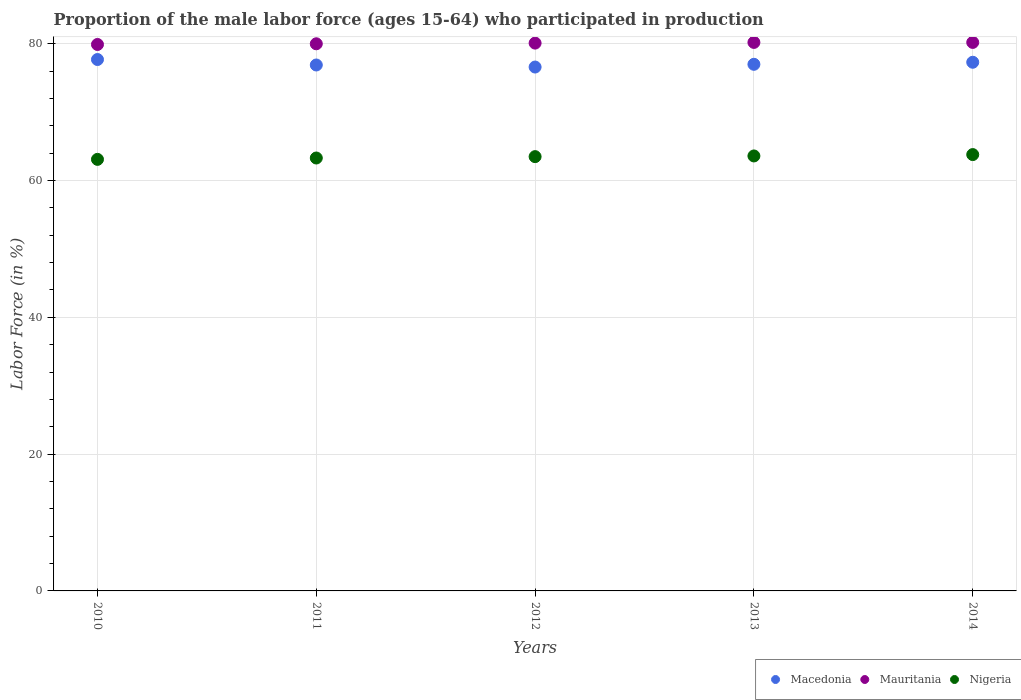What is the proportion of the male labor force who participated in production in Macedonia in 2012?
Offer a very short reply. 76.6. Across all years, what is the maximum proportion of the male labor force who participated in production in Mauritania?
Provide a short and direct response. 80.2. Across all years, what is the minimum proportion of the male labor force who participated in production in Macedonia?
Offer a very short reply. 76.6. What is the total proportion of the male labor force who participated in production in Macedonia in the graph?
Offer a terse response. 385.5. What is the difference between the proportion of the male labor force who participated in production in Macedonia in 2013 and that in 2014?
Offer a terse response. -0.3. What is the difference between the proportion of the male labor force who participated in production in Mauritania in 2012 and the proportion of the male labor force who participated in production in Macedonia in 2010?
Provide a succinct answer. 2.4. What is the average proportion of the male labor force who participated in production in Macedonia per year?
Ensure brevity in your answer.  77.1. In the year 2010, what is the difference between the proportion of the male labor force who participated in production in Nigeria and proportion of the male labor force who participated in production in Mauritania?
Your answer should be very brief. -16.8. In how many years, is the proportion of the male labor force who participated in production in Macedonia greater than 64 %?
Ensure brevity in your answer.  5. What is the ratio of the proportion of the male labor force who participated in production in Mauritania in 2011 to that in 2012?
Make the answer very short. 1. What is the difference between the highest and the second highest proportion of the male labor force who participated in production in Macedonia?
Make the answer very short. 0.4. What is the difference between the highest and the lowest proportion of the male labor force who participated in production in Mauritania?
Ensure brevity in your answer.  0.3. In how many years, is the proportion of the male labor force who participated in production in Mauritania greater than the average proportion of the male labor force who participated in production in Mauritania taken over all years?
Make the answer very short. 3. Does the proportion of the male labor force who participated in production in Macedonia monotonically increase over the years?
Provide a short and direct response. No. Is the proportion of the male labor force who participated in production in Mauritania strictly greater than the proportion of the male labor force who participated in production in Nigeria over the years?
Your answer should be very brief. Yes. Is the proportion of the male labor force who participated in production in Macedonia strictly less than the proportion of the male labor force who participated in production in Mauritania over the years?
Your answer should be compact. Yes. How many years are there in the graph?
Your response must be concise. 5. Does the graph contain any zero values?
Your answer should be compact. No. Does the graph contain grids?
Your answer should be compact. Yes. What is the title of the graph?
Your response must be concise. Proportion of the male labor force (ages 15-64) who participated in production. Does "Latin America(developing only)" appear as one of the legend labels in the graph?
Make the answer very short. No. What is the label or title of the X-axis?
Ensure brevity in your answer.  Years. What is the label or title of the Y-axis?
Your response must be concise. Labor Force (in %). What is the Labor Force (in %) in Macedonia in 2010?
Keep it short and to the point. 77.7. What is the Labor Force (in %) of Mauritania in 2010?
Your answer should be compact. 79.9. What is the Labor Force (in %) of Nigeria in 2010?
Provide a succinct answer. 63.1. What is the Labor Force (in %) of Macedonia in 2011?
Ensure brevity in your answer.  76.9. What is the Labor Force (in %) of Nigeria in 2011?
Keep it short and to the point. 63.3. What is the Labor Force (in %) of Macedonia in 2012?
Ensure brevity in your answer.  76.6. What is the Labor Force (in %) of Mauritania in 2012?
Ensure brevity in your answer.  80.1. What is the Labor Force (in %) of Nigeria in 2012?
Offer a very short reply. 63.5. What is the Labor Force (in %) of Macedonia in 2013?
Ensure brevity in your answer.  77. What is the Labor Force (in %) of Mauritania in 2013?
Your answer should be very brief. 80.2. What is the Labor Force (in %) of Nigeria in 2013?
Provide a succinct answer. 63.6. What is the Labor Force (in %) in Macedonia in 2014?
Provide a short and direct response. 77.3. What is the Labor Force (in %) in Mauritania in 2014?
Your answer should be compact. 80.2. What is the Labor Force (in %) of Nigeria in 2014?
Give a very brief answer. 63.8. Across all years, what is the maximum Labor Force (in %) in Macedonia?
Ensure brevity in your answer.  77.7. Across all years, what is the maximum Labor Force (in %) in Mauritania?
Offer a very short reply. 80.2. Across all years, what is the maximum Labor Force (in %) of Nigeria?
Keep it short and to the point. 63.8. Across all years, what is the minimum Labor Force (in %) of Macedonia?
Ensure brevity in your answer.  76.6. Across all years, what is the minimum Labor Force (in %) of Mauritania?
Keep it short and to the point. 79.9. Across all years, what is the minimum Labor Force (in %) in Nigeria?
Offer a terse response. 63.1. What is the total Labor Force (in %) of Macedonia in the graph?
Your answer should be very brief. 385.5. What is the total Labor Force (in %) of Mauritania in the graph?
Offer a terse response. 400.4. What is the total Labor Force (in %) in Nigeria in the graph?
Your answer should be compact. 317.3. What is the difference between the Labor Force (in %) in Macedonia in 2010 and that in 2011?
Your answer should be compact. 0.8. What is the difference between the Labor Force (in %) of Nigeria in 2010 and that in 2011?
Ensure brevity in your answer.  -0.2. What is the difference between the Labor Force (in %) of Macedonia in 2010 and that in 2012?
Give a very brief answer. 1.1. What is the difference between the Labor Force (in %) of Mauritania in 2010 and that in 2012?
Your answer should be compact. -0.2. What is the difference between the Labor Force (in %) in Macedonia in 2010 and that in 2013?
Provide a short and direct response. 0.7. What is the difference between the Labor Force (in %) in Mauritania in 2010 and that in 2013?
Provide a succinct answer. -0.3. What is the difference between the Labor Force (in %) in Nigeria in 2010 and that in 2013?
Your answer should be very brief. -0.5. What is the difference between the Labor Force (in %) of Macedonia in 2010 and that in 2014?
Provide a short and direct response. 0.4. What is the difference between the Labor Force (in %) of Mauritania in 2010 and that in 2014?
Keep it short and to the point. -0.3. What is the difference between the Labor Force (in %) of Nigeria in 2010 and that in 2014?
Your response must be concise. -0.7. What is the difference between the Labor Force (in %) in Mauritania in 2011 and that in 2012?
Give a very brief answer. -0.1. What is the difference between the Labor Force (in %) of Nigeria in 2011 and that in 2012?
Make the answer very short. -0.2. What is the difference between the Labor Force (in %) of Macedonia in 2011 and that in 2014?
Offer a very short reply. -0.4. What is the difference between the Labor Force (in %) in Mauritania in 2011 and that in 2014?
Offer a terse response. -0.2. What is the difference between the Labor Force (in %) of Mauritania in 2012 and that in 2013?
Offer a terse response. -0.1. What is the difference between the Labor Force (in %) in Macedonia in 2010 and the Labor Force (in %) in Nigeria in 2012?
Make the answer very short. 14.2. What is the difference between the Labor Force (in %) of Mauritania in 2010 and the Labor Force (in %) of Nigeria in 2012?
Ensure brevity in your answer.  16.4. What is the difference between the Labor Force (in %) of Macedonia in 2010 and the Labor Force (in %) of Nigeria in 2013?
Keep it short and to the point. 14.1. What is the difference between the Labor Force (in %) in Macedonia in 2010 and the Labor Force (in %) in Mauritania in 2014?
Provide a succinct answer. -2.5. What is the difference between the Labor Force (in %) in Macedonia in 2010 and the Labor Force (in %) in Nigeria in 2014?
Make the answer very short. 13.9. What is the difference between the Labor Force (in %) of Macedonia in 2011 and the Labor Force (in %) of Mauritania in 2012?
Make the answer very short. -3.2. What is the difference between the Labor Force (in %) of Mauritania in 2011 and the Labor Force (in %) of Nigeria in 2012?
Provide a short and direct response. 16.5. What is the difference between the Labor Force (in %) of Macedonia in 2011 and the Labor Force (in %) of Mauritania in 2013?
Offer a terse response. -3.3. What is the difference between the Labor Force (in %) in Macedonia in 2011 and the Labor Force (in %) in Nigeria in 2013?
Ensure brevity in your answer.  13.3. What is the difference between the Labor Force (in %) of Mauritania in 2011 and the Labor Force (in %) of Nigeria in 2014?
Keep it short and to the point. 16.2. What is the difference between the Labor Force (in %) of Macedonia in 2012 and the Labor Force (in %) of Mauritania in 2013?
Provide a short and direct response. -3.6. What is the difference between the Labor Force (in %) in Mauritania in 2012 and the Labor Force (in %) in Nigeria in 2013?
Provide a succinct answer. 16.5. What is the difference between the Labor Force (in %) of Macedonia in 2012 and the Labor Force (in %) of Nigeria in 2014?
Offer a terse response. 12.8. What is the difference between the Labor Force (in %) in Mauritania in 2012 and the Labor Force (in %) in Nigeria in 2014?
Ensure brevity in your answer.  16.3. What is the difference between the Labor Force (in %) of Macedonia in 2013 and the Labor Force (in %) of Mauritania in 2014?
Provide a short and direct response. -3.2. What is the difference between the Labor Force (in %) in Macedonia in 2013 and the Labor Force (in %) in Nigeria in 2014?
Make the answer very short. 13.2. What is the average Labor Force (in %) of Macedonia per year?
Your answer should be compact. 77.1. What is the average Labor Force (in %) in Mauritania per year?
Make the answer very short. 80.08. What is the average Labor Force (in %) of Nigeria per year?
Make the answer very short. 63.46. In the year 2011, what is the difference between the Labor Force (in %) of Macedonia and Labor Force (in %) of Mauritania?
Provide a succinct answer. -3.1. In the year 2011, what is the difference between the Labor Force (in %) of Macedonia and Labor Force (in %) of Nigeria?
Provide a succinct answer. 13.6. In the year 2012, what is the difference between the Labor Force (in %) of Macedonia and Labor Force (in %) of Nigeria?
Keep it short and to the point. 13.1. In the year 2013, what is the difference between the Labor Force (in %) in Macedonia and Labor Force (in %) in Mauritania?
Keep it short and to the point. -3.2. In the year 2013, what is the difference between the Labor Force (in %) of Macedonia and Labor Force (in %) of Nigeria?
Ensure brevity in your answer.  13.4. In the year 2013, what is the difference between the Labor Force (in %) in Mauritania and Labor Force (in %) in Nigeria?
Your answer should be compact. 16.6. In the year 2014, what is the difference between the Labor Force (in %) in Macedonia and Labor Force (in %) in Nigeria?
Give a very brief answer. 13.5. In the year 2014, what is the difference between the Labor Force (in %) in Mauritania and Labor Force (in %) in Nigeria?
Your answer should be very brief. 16.4. What is the ratio of the Labor Force (in %) of Macedonia in 2010 to that in 2011?
Keep it short and to the point. 1.01. What is the ratio of the Labor Force (in %) of Mauritania in 2010 to that in 2011?
Keep it short and to the point. 1. What is the ratio of the Labor Force (in %) of Macedonia in 2010 to that in 2012?
Offer a terse response. 1.01. What is the ratio of the Labor Force (in %) of Mauritania in 2010 to that in 2012?
Provide a succinct answer. 1. What is the ratio of the Labor Force (in %) in Macedonia in 2010 to that in 2013?
Keep it short and to the point. 1.01. What is the ratio of the Labor Force (in %) in Mauritania in 2010 to that in 2013?
Make the answer very short. 1. What is the ratio of the Labor Force (in %) of Nigeria in 2010 to that in 2014?
Ensure brevity in your answer.  0.99. What is the ratio of the Labor Force (in %) of Macedonia in 2011 to that in 2012?
Make the answer very short. 1. What is the ratio of the Labor Force (in %) in Mauritania in 2011 to that in 2012?
Ensure brevity in your answer.  1. What is the ratio of the Labor Force (in %) of Macedonia in 2011 to that in 2013?
Your answer should be very brief. 1. What is the ratio of the Labor Force (in %) of Nigeria in 2011 to that in 2013?
Your answer should be compact. 1. What is the ratio of the Labor Force (in %) of Macedonia in 2011 to that in 2014?
Your answer should be very brief. 0.99. What is the ratio of the Labor Force (in %) of Macedonia in 2012 to that in 2013?
Ensure brevity in your answer.  0.99. What is the ratio of the Labor Force (in %) of Nigeria in 2012 to that in 2013?
Give a very brief answer. 1. What is the ratio of the Labor Force (in %) in Macedonia in 2012 to that in 2014?
Offer a very short reply. 0.99. What is the difference between the highest and the second highest Labor Force (in %) in Macedonia?
Give a very brief answer. 0.4. 